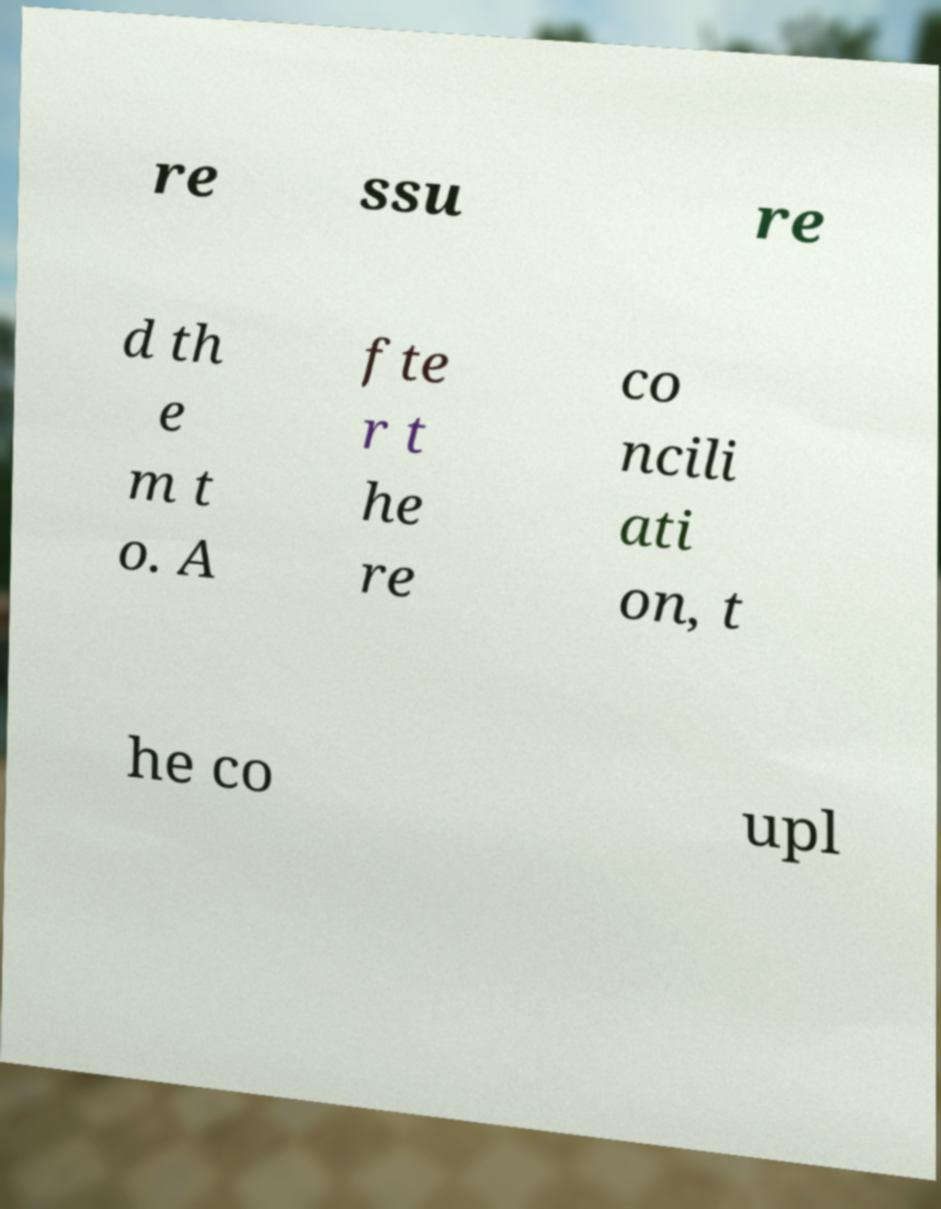I need the written content from this picture converted into text. Can you do that? re ssu re d th e m t o. A fte r t he re co ncili ati on, t he co upl 